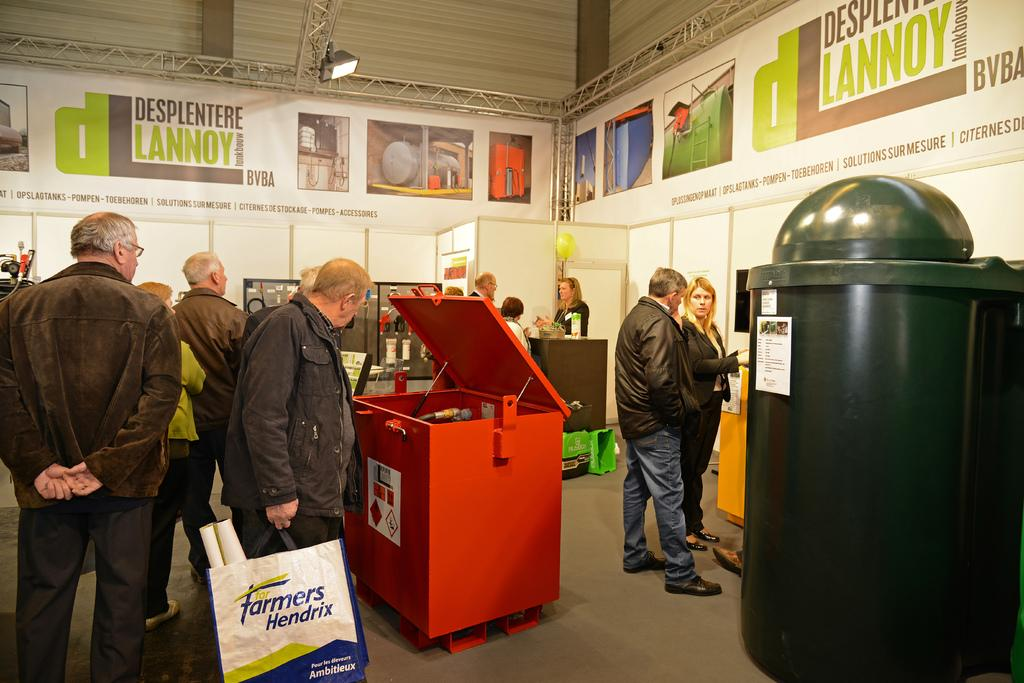Provide a one-sentence caption for the provided image. people inside of a event for Desplentere Lannoy. 